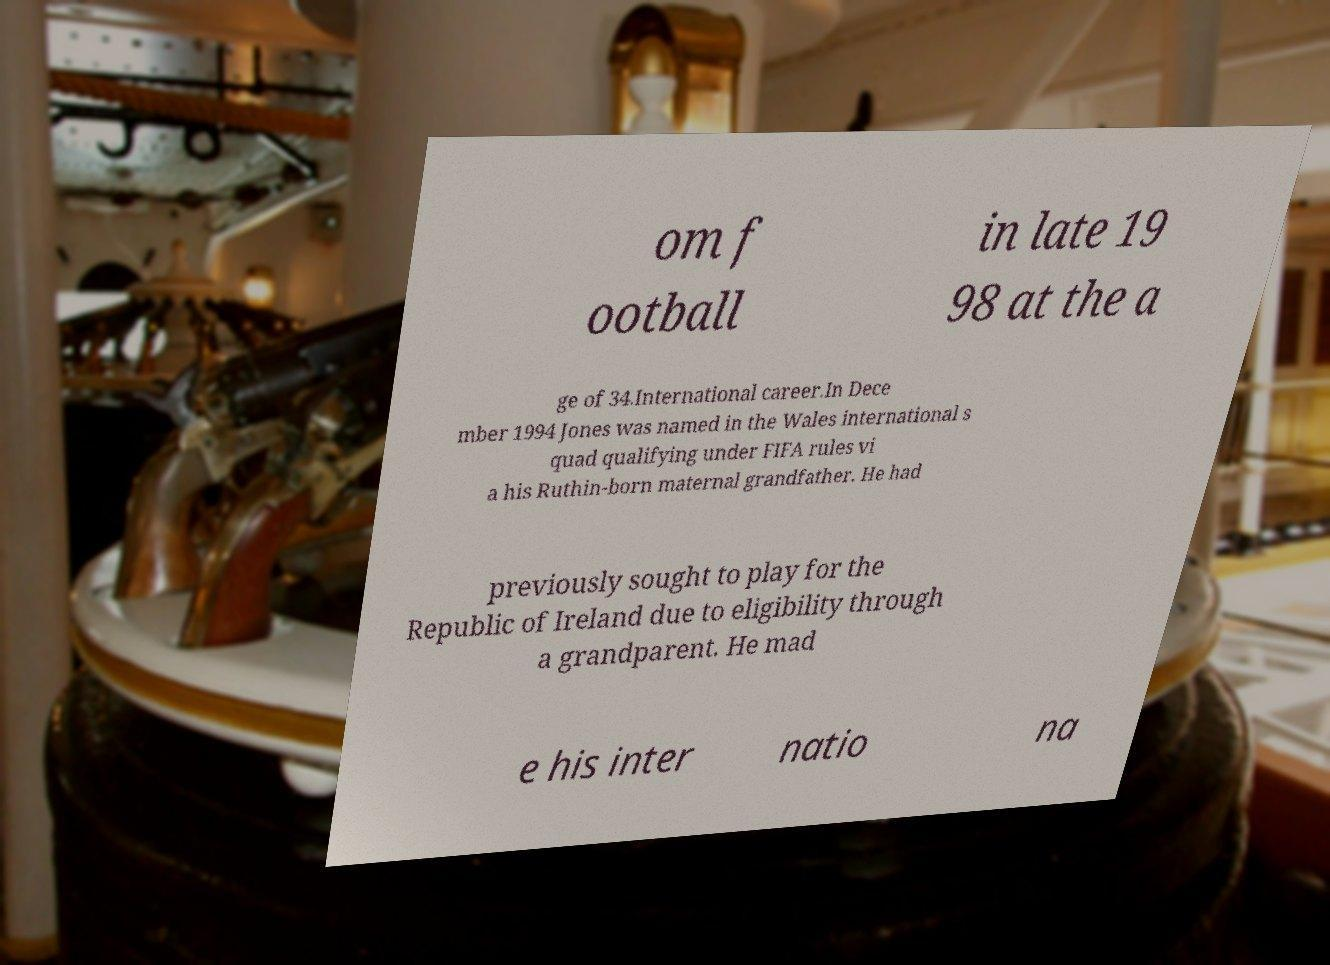Could you extract and type out the text from this image? om f ootball in late 19 98 at the a ge of 34.International career.In Dece mber 1994 Jones was named in the Wales international s quad qualifying under FIFA rules vi a his Ruthin-born maternal grandfather. He had previously sought to play for the Republic of Ireland due to eligibility through a grandparent. He mad e his inter natio na 